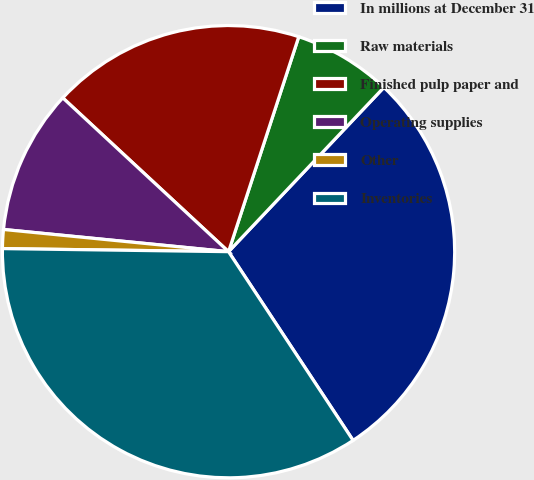Convert chart to OTSL. <chart><loc_0><loc_0><loc_500><loc_500><pie_chart><fcel>In millions at December 31<fcel>Raw materials<fcel>Finished pulp paper and<fcel>Operating supplies<fcel>Other<fcel>Inventories<nl><fcel>28.66%<fcel>7.03%<fcel>18.12%<fcel>10.34%<fcel>1.35%<fcel>34.5%<nl></chart> 